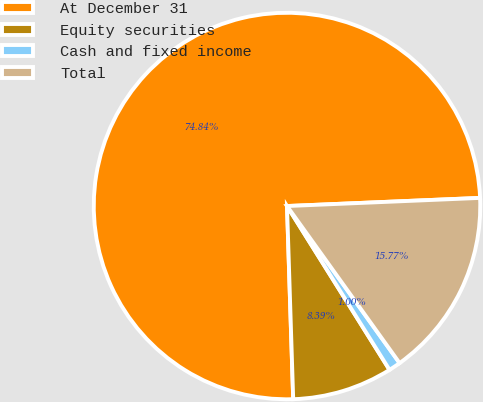Convert chart. <chart><loc_0><loc_0><loc_500><loc_500><pie_chart><fcel>At December 31<fcel>Equity securities<fcel>Cash and fixed income<fcel>Total<nl><fcel>74.84%<fcel>8.39%<fcel>1.0%<fcel>15.77%<nl></chart> 